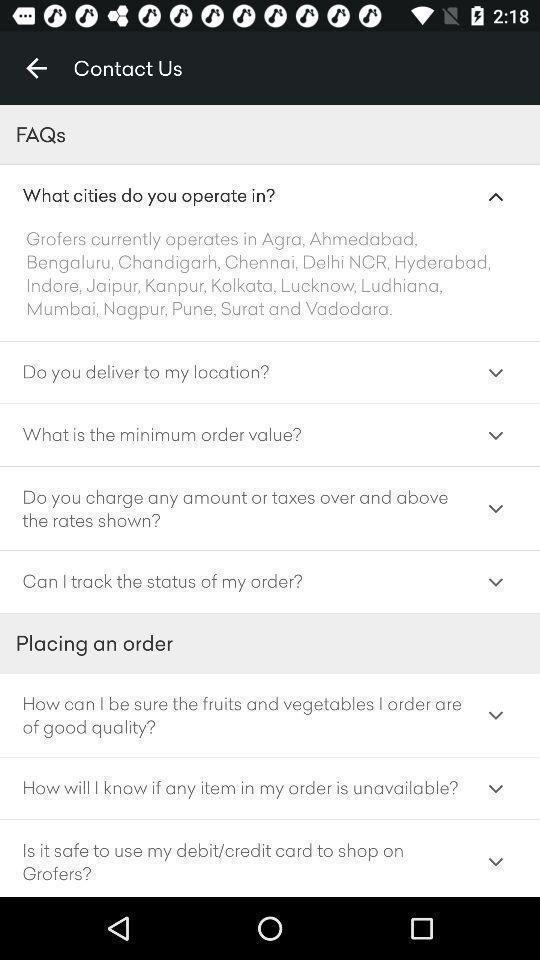Provide a detailed account of this screenshot. Screen showing contact us page. 